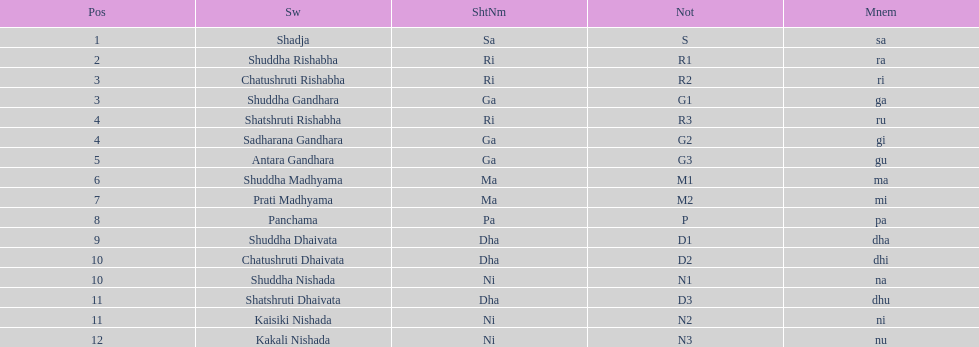What swara is above shatshruti dhaivata? Shuddha Nishada. 